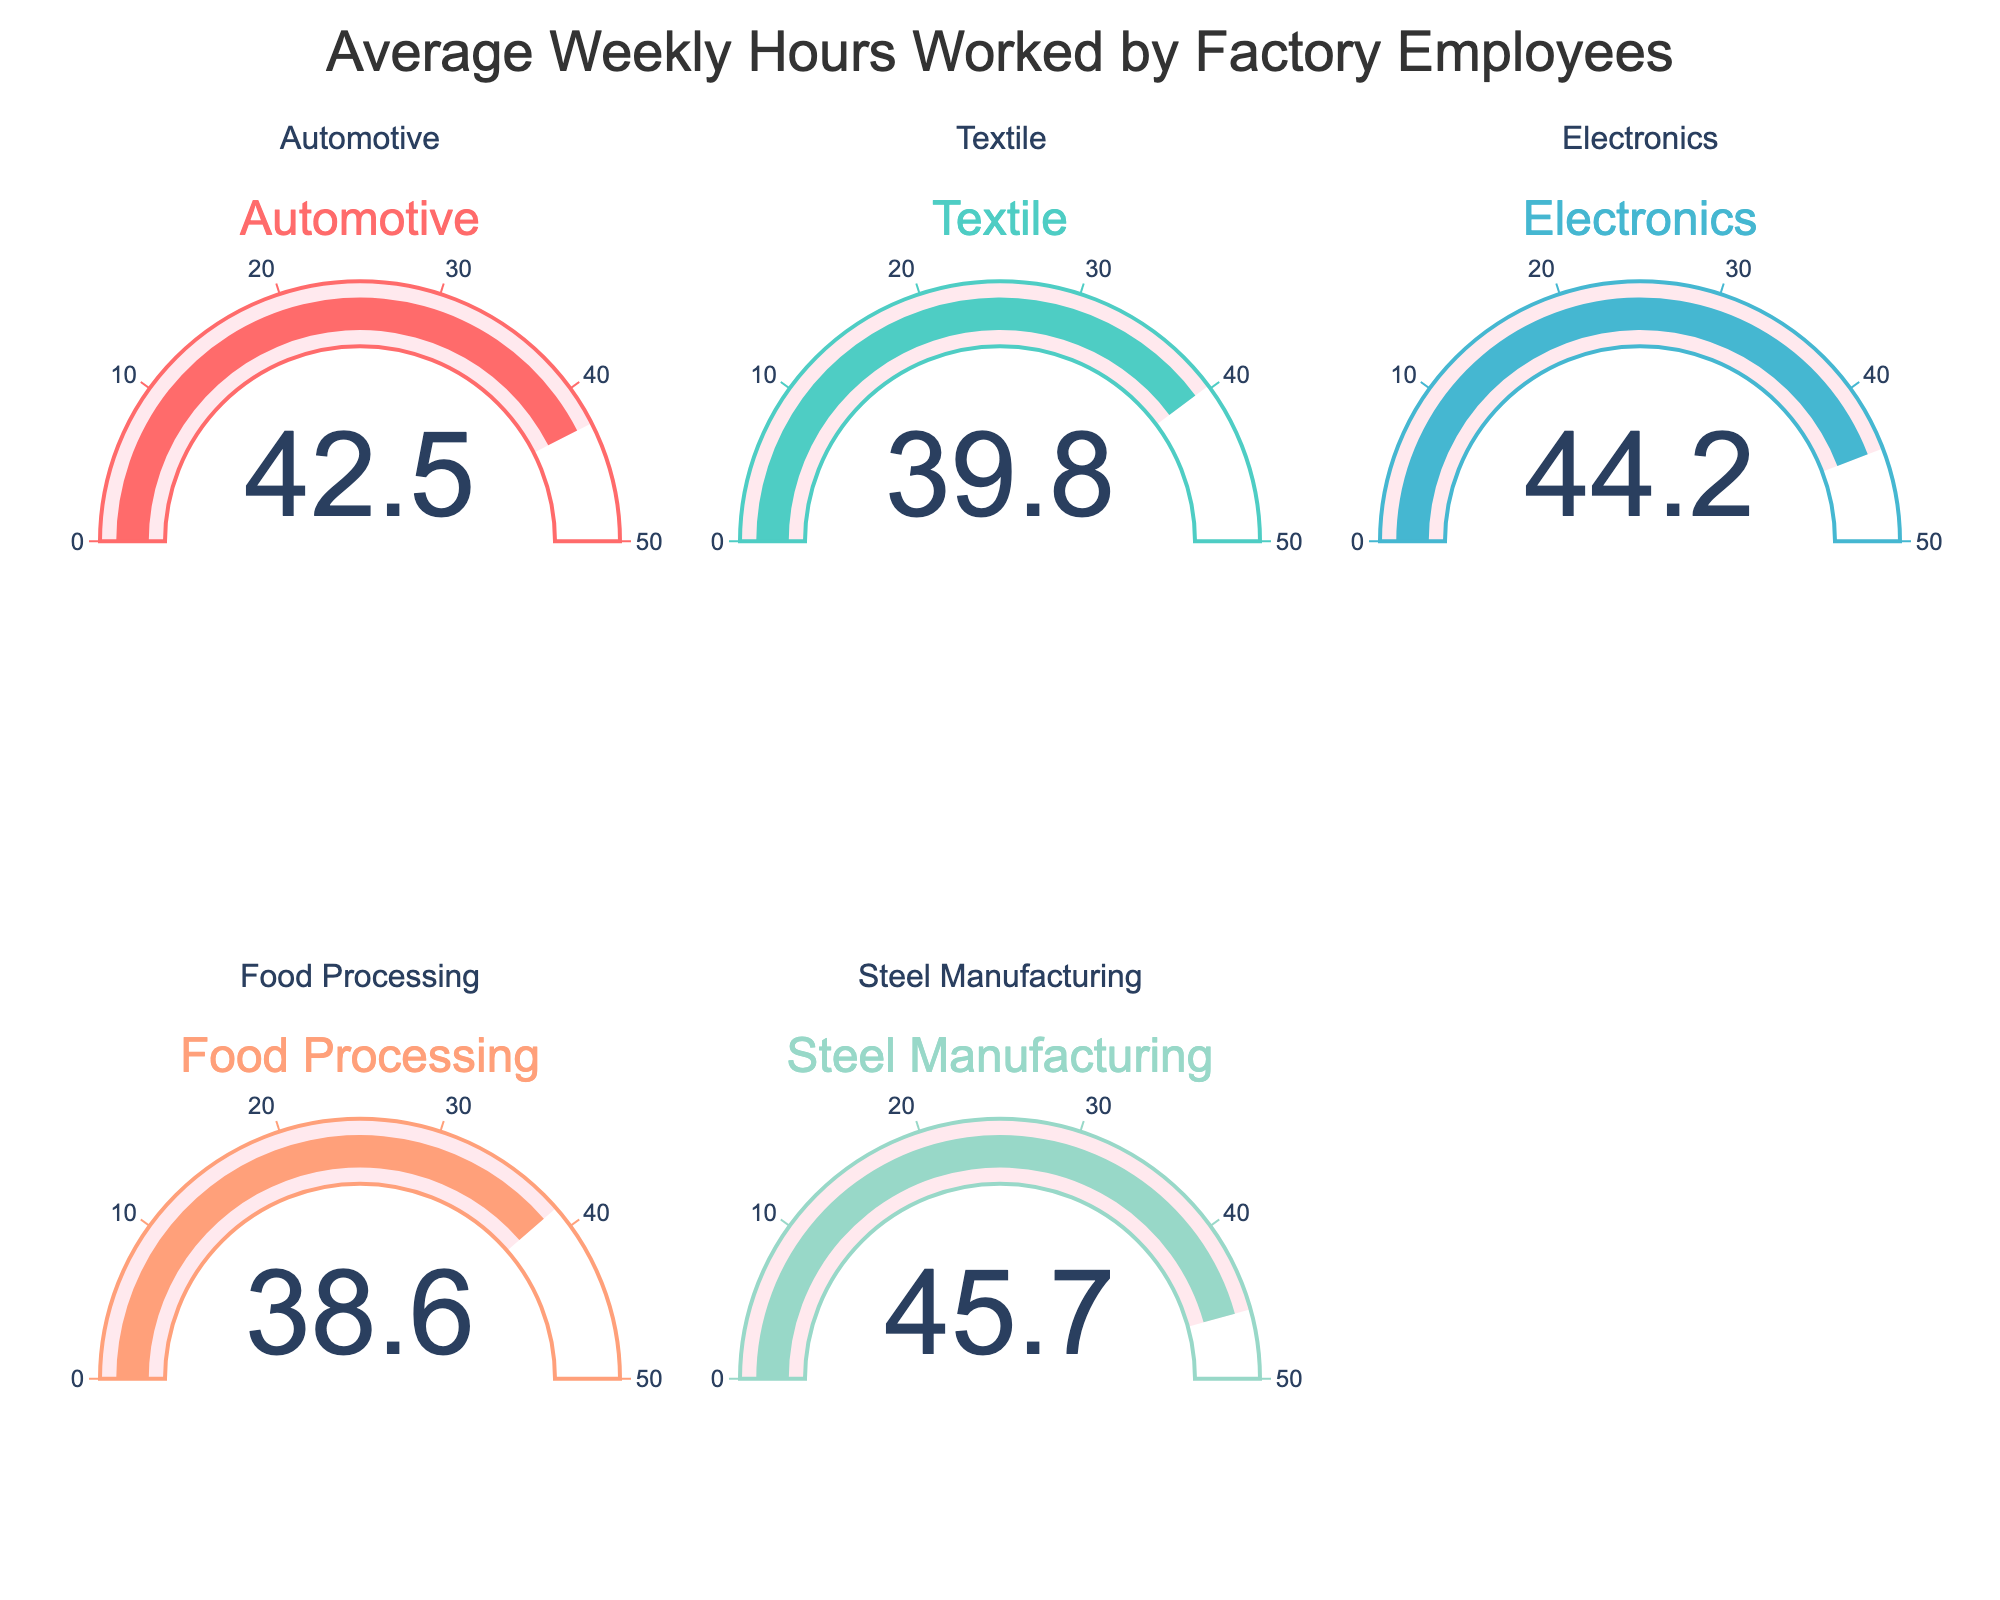What is the average weekly hours worked in the Electronics industry? Look at the gauge displaying the average weekly hours for the Electronics industry. The number shown is 44.2 hours.
Answer: 44.2 Which industry has the highest average weekly hours worked? Compare the values on all gauges and identify the highest number. The Steel Manufacturing gauge shows 45.7 hours, which is the highest.
Answer: Steel Manufacturing Which industry has the lowest average weekly hours worked? Compare the values on all gauges and identify the smallest number. The Food Processing gauge shows 38.6 hours, which is the lowest.
Answer: Food Processing What is the difference between the average weekly hours worked in the Automotive and Textile industries? Subtract the value for Textile (39.8 hours) from the value for Automotive (42.5 hours). The difference is 42.5 - 39.8 = 2.7 hours.
Answer: 2.7 How would you rank the industries from the lowest to the highest average weekly hours worked? List all values and sort them in ascending order: Food Processing (38.6), Textile (39.8), Automotive (42.5), Electronics (44.2), Steel Manufacturing (45.7).
Answer: Food Processing, Textile, Automotive, Electronics, Steel Manufacturing What is the average of the average weekly hours worked across all industries? Sum the values of all industries and then divide by the number of industries. The sum is 42.5 + 39.8 + 44.2 + 38.6 + 45.7 = 210.8. The average is 210.8 / 5 = 42.16 hours.
Answer: 42.16 How much more does the Steel Manufacturing industry work on average compared to the Electronics industry? Subtract the value for Electronics (44.2 hours) from the value for Steel Manufacturing (45.7 hours). The difference is 45.7 - 44.2 = 1.5 hours.
Answer: 1.5 Which two industries have the closest average weekly hours worked? Check the differences between the values of all industries and find the smallest difference. The closest values are for Automotive (42.5) and Electronics (44.2), with a difference of 44.2 - 42.5 = 1.7 hours.
Answer: Automotive and Electronics 